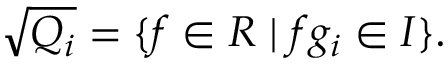Convert formula to latex. <formula><loc_0><loc_0><loc_500><loc_500>{ \sqrt { Q _ { i } } } = \{ f \in R | f g _ { i } \in I \} .</formula> 